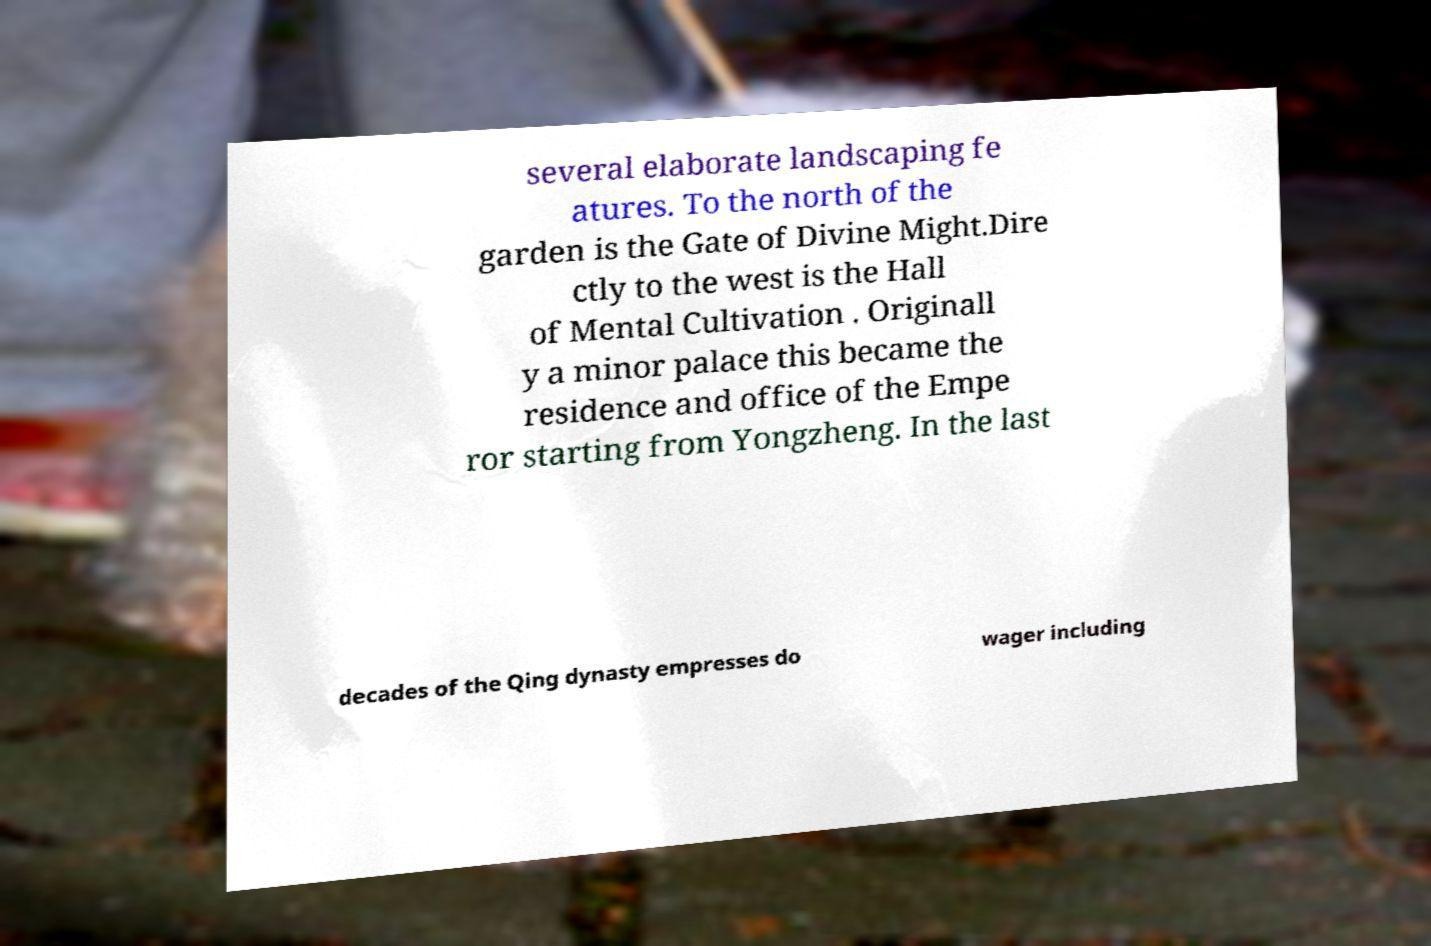For documentation purposes, I need the text within this image transcribed. Could you provide that? several elaborate landscaping fe atures. To the north of the garden is the Gate of Divine Might.Dire ctly to the west is the Hall of Mental Cultivation . Originall y a minor palace this became the residence and office of the Empe ror starting from Yongzheng. In the last decades of the Qing dynasty empresses do wager including 